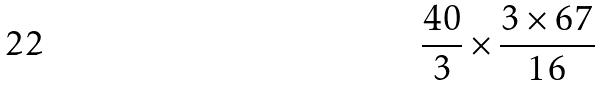<formula> <loc_0><loc_0><loc_500><loc_500>\frac { 4 0 } { 3 } \times \frac { 3 \times 6 7 } { 1 6 }</formula> 